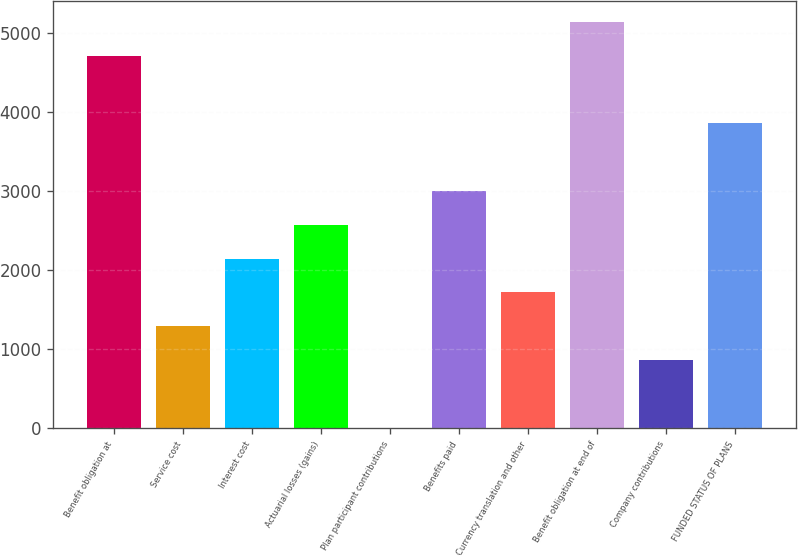<chart> <loc_0><loc_0><loc_500><loc_500><bar_chart><fcel>Benefit obligation at<fcel>Service cost<fcel>Interest cost<fcel>Actuarial losses (gains)<fcel>Plan participant contributions<fcel>Benefits paid<fcel>Currency translation and other<fcel>Benefit obligation at end of<fcel>Company contributions<fcel>FUNDED STATUS OF PLANS<nl><fcel>4709.93<fcel>1288.09<fcel>2143.55<fcel>2571.28<fcel>4.9<fcel>2999.01<fcel>1715.82<fcel>5137.66<fcel>860.36<fcel>3854.47<nl></chart> 